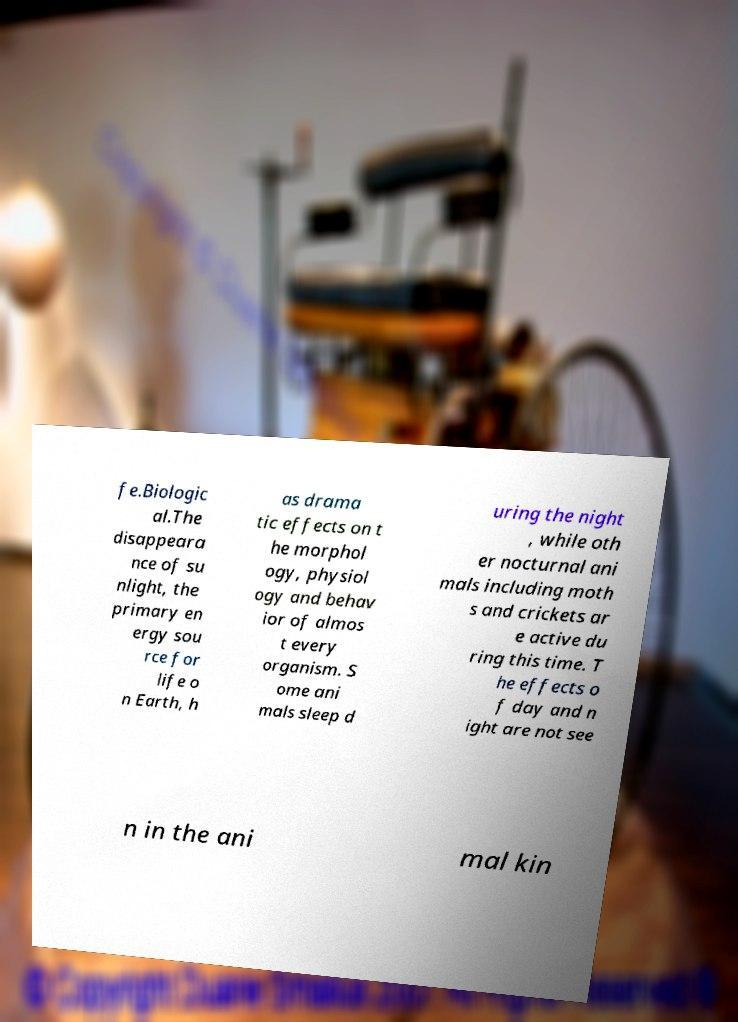For documentation purposes, I need the text within this image transcribed. Could you provide that? fe.Biologic al.The disappeara nce of su nlight, the primary en ergy sou rce for life o n Earth, h as drama tic effects on t he morphol ogy, physiol ogy and behav ior of almos t every organism. S ome ani mals sleep d uring the night , while oth er nocturnal ani mals including moth s and crickets ar e active du ring this time. T he effects o f day and n ight are not see n in the ani mal kin 